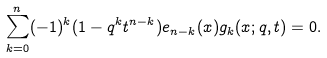Convert formula to latex. <formula><loc_0><loc_0><loc_500><loc_500>\sum _ { k = 0 } ^ { n } ( - 1 ) ^ { k } ( 1 - q ^ { k } t ^ { n - k } ) e _ { n - k } ( x ) g _ { k } ( x ; q , t ) = 0 .</formula> 